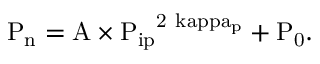Convert formula to latex. <formula><loc_0><loc_0><loc_500><loc_500>{ P _ { n } } = \mathrm { { A } \times \mathrm { { P _ { i p } } ^ { 2 \ k a p p a _ { p } } + \mathrm { { P _ { 0 } } . } } }</formula> 